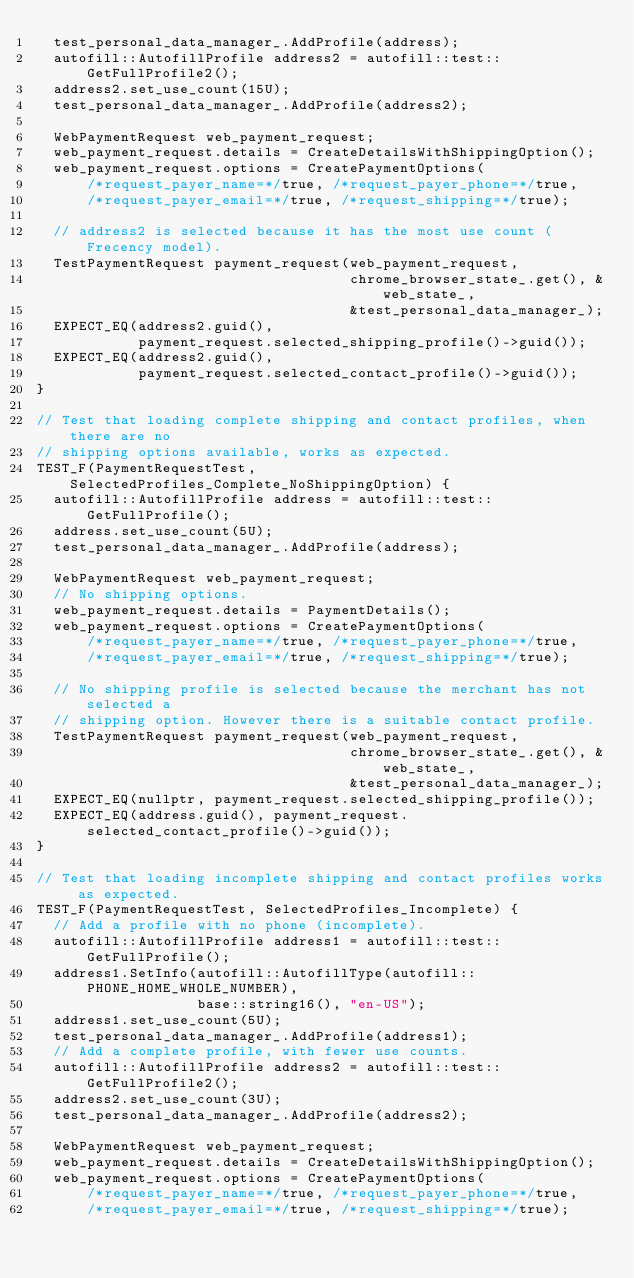Convert code to text. <code><loc_0><loc_0><loc_500><loc_500><_ObjectiveC_>  test_personal_data_manager_.AddProfile(address);
  autofill::AutofillProfile address2 = autofill::test::GetFullProfile2();
  address2.set_use_count(15U);
  test_personal_data_manager_.AddProfile(address2);

  WebPaymentRequest web_payment_request;
  web_payment_request.details = CreateDetailsWithShippingOption();
  web_payment_request.options = CreatePaymentOptions(
      /*request_payer_name=*/true, /*request_payer_phone=*/true,
      /*request_payer_email=*/true, /*request_shipping=*/true);

  // address2 is selected because it has the most use count (Frecency model).
  TestPaymentRequest payment_request(web_payment_request,
                                     chrome_browser_state_.get(), &web_state_,
                                     &test_personal_data_manager_);
  EXPECT_EQ(address2.guid(),
            payment_request.selected_shipping_profile()->guid());
  EXPECT_EQ(address2.guid(),
            payment_request.selected_contact_profile()->guid());
}

// Test that loading complete shipping and contact profiles, when there are no
// shipping options available, works as expected.
TEST_F(PaymentRequestTest, SelectedProfiles_Complete_NoShippingOption) {
  autofill::AutofillProfile address = autofill::test::GetFullProfile();
  address.set_use_count(5U);
  test_personal_data_manager_.AddProfile(address);

  WebPaymentRequest web_payment_request;
  // No shipping options.
  web_payment_request.details = PaymentDetails();
  web_payment_request.options = CreatePaymentOptions(
      /*request_payer_name=*/true, /*request_payer_phone=*/true,
      /*request_payer_email=*/true, /*request_shipping=*/true);

  // No shipping profile is selected because the merchant has not selected a
  // shipping option. However there is a suitable contact profile.
  TestPaymentRequest payment_request(web_payment_request,
                                     chrome_browser_state_.get(), &web_state_,
                                     &test_personal_data_manager_);
  EXPECT_EQ(nullptr, payment_request.selected_shipping_profile());
  EXPECT_EQ(address.guid(), payment_request.selected_contact_profile()->guid());
}

// Test that loading incomplete shipping and contact profiles works as expected.
TEST_F(PaymentRequestTest, SelectedProfiles_Incomplete) {
  // Add a profile with no phone (incomplete).
  autofill::AutofillProfile address1 = autofill::test::GetFullProfile();
  address1.SetInfo(autofill::AutofillType(autofill::PHONE_HOME_WHOLE_NUMBER),
                   base::string16(), "en-US");
  address1.set_use_count(5U);
  test_personal_data_manager_.AddProfile(address1);
  // Add a complete profile, with fewer use counts.
  autofill::AutofillProfile address2 = autofill::test::GetFullProfile2();
  address2.set_use_count(3U);
  test_personal_data_manager_.AddProfile(address2);

  WebPaymentRequest web_payment_request;
  web_payment_request.details = CreateDetailsWithShippingOption();
  web_payment_request.options = CreatePaymentOptions(
      /*request_payer_name=*/true, /*request_payer_phone=*/true,
      /*request_payer_email=*/true, /*request_shipping=*/true);
</code> 